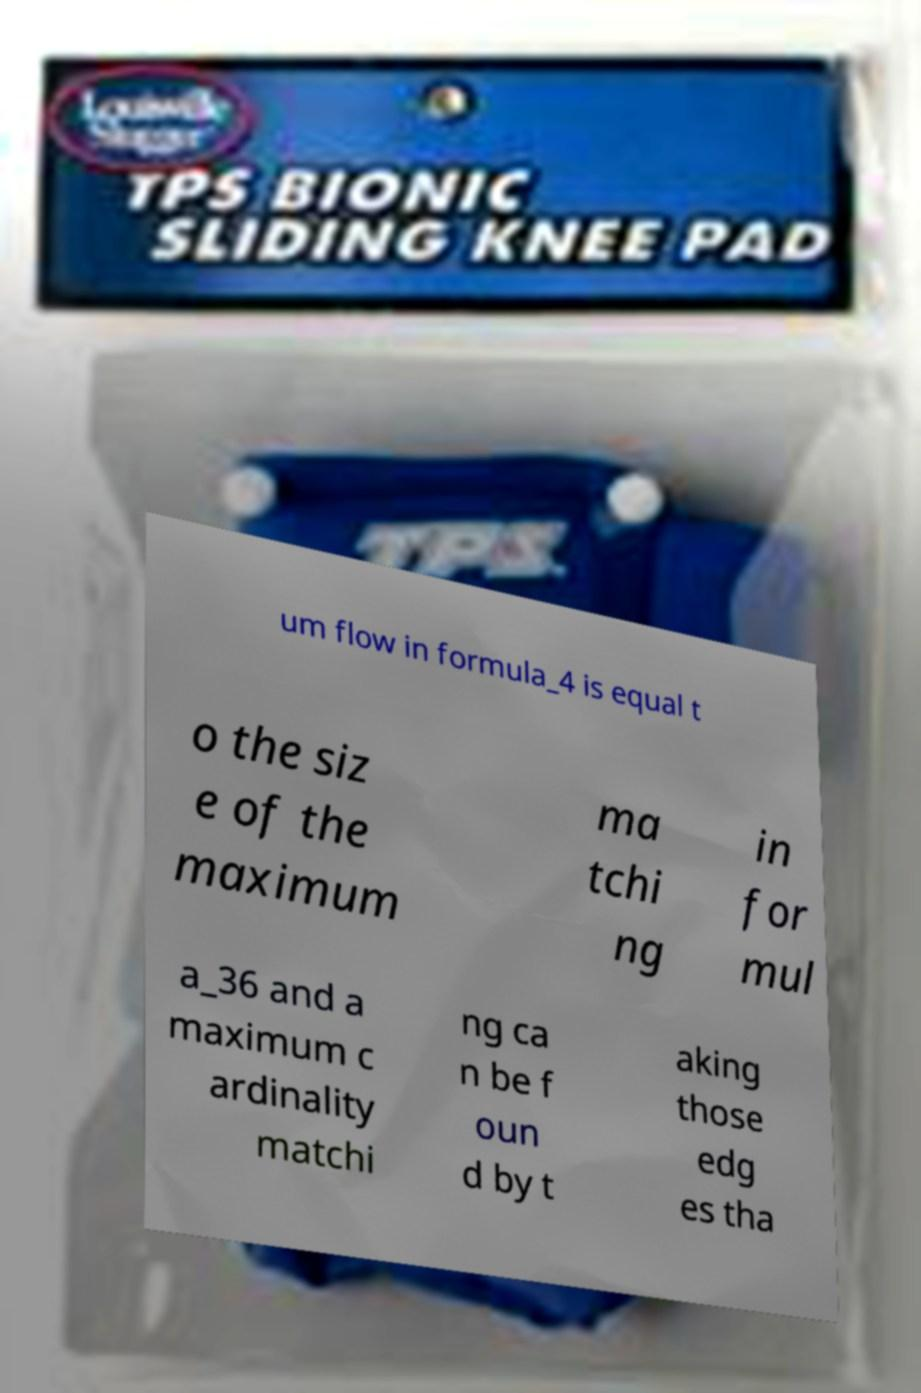Can you accurately transcribe the text from the provided image for me? um flow in formula_4 is equal t o the siz e of the maximum ma tchi ng in for mul a_36 and a maximum c ardinality matchi ng ca n be f oun d by t aking those edg es tha 